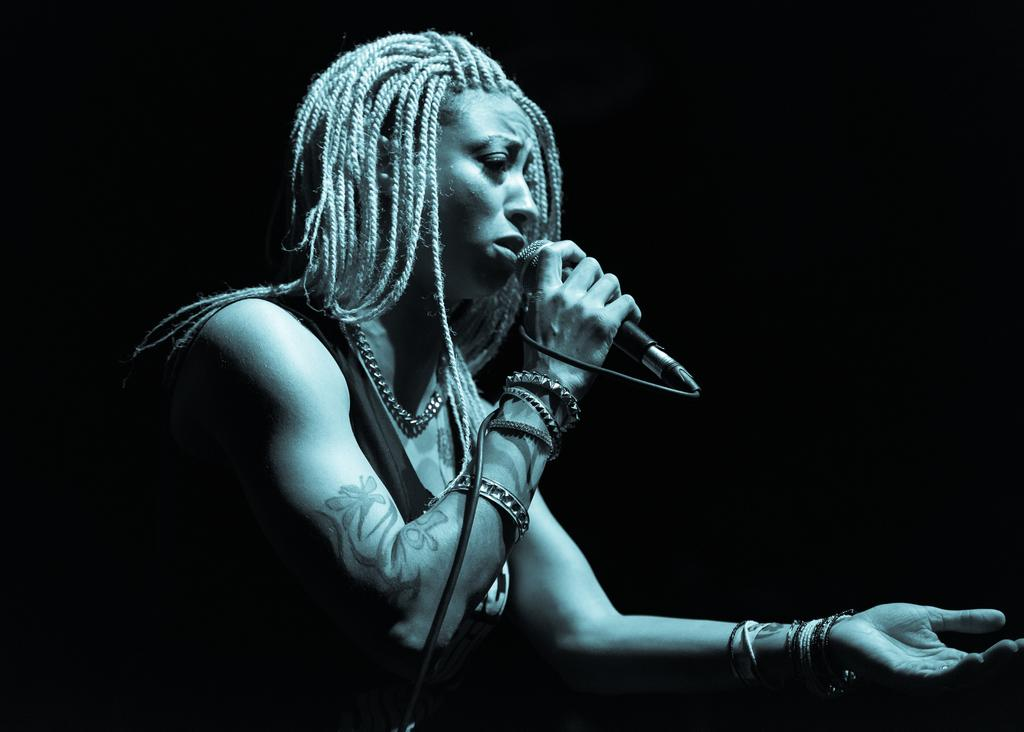What is the color scheme of the image? The image is black and white. Who is the main subject in the image? There is a woman in the image. What is the woman doing in the image? The woman is singing. What object is the woman holding in the image? The woman is holding a microphone. How many sheep are visible in the image? There are no sheep present in the image. What type of currency is the woman holding in the image? There is no money visible in the image; the woman is holding a microphone. 